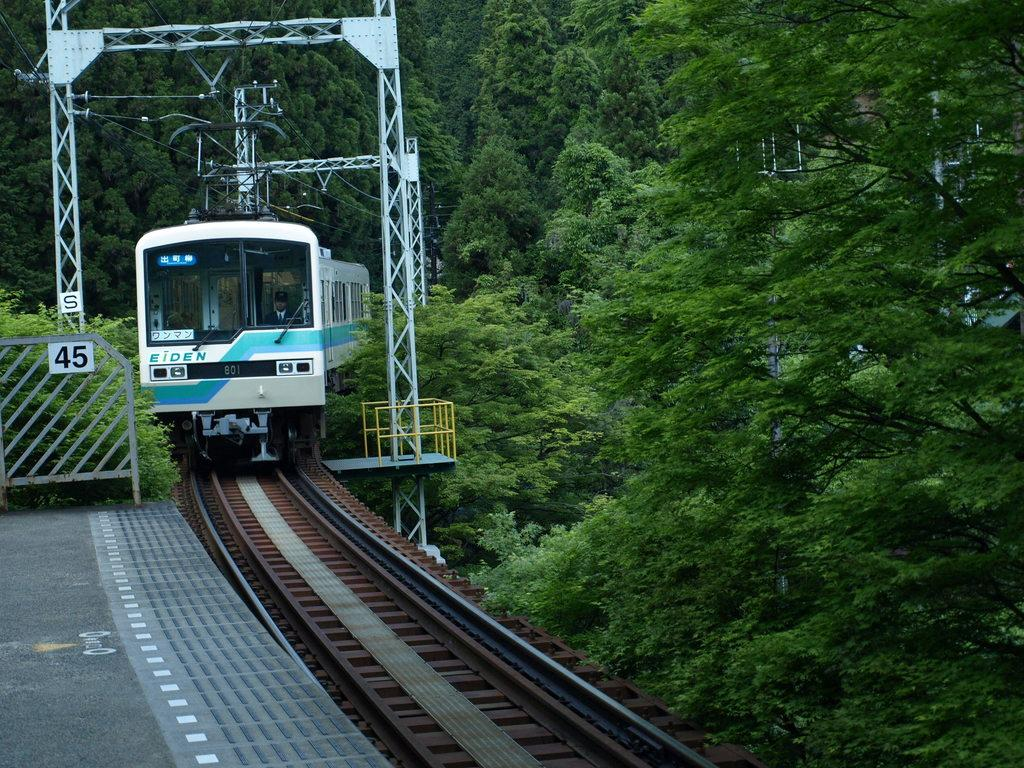What is the main subject of the image? The main subject of the image is a train. Where is the train located in the image? The train is on a track in the image. What can be seen on either side of the track? There are plants on either side of the track. What type of ball is being used to water the plants in the image? There is no ball present in the image, and the plants are not being watered. 